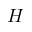Convert formula to latex. <formula><loc_0><loc_0><loc_500><loc_500>H</formula> 